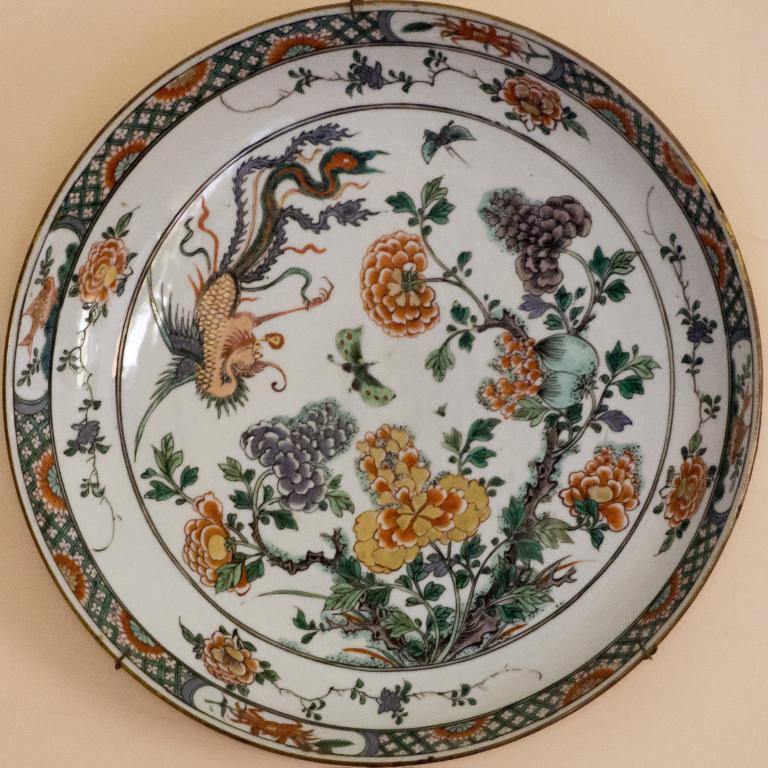What object is present in the image that can hold food? There is a plate in the image that can hold food. What can be said about the appearance of the plate? The plate is colorful. What types of food items are on the plate? There are fruits on the plate. Are there any other decorative elements on the plate? Yes, there are flowers and animals on the plate. What type of record can be heard playing in the background of the image? There is no record or sound present in the image; it is a still image of a plate with fruits, flowers, and animals. 